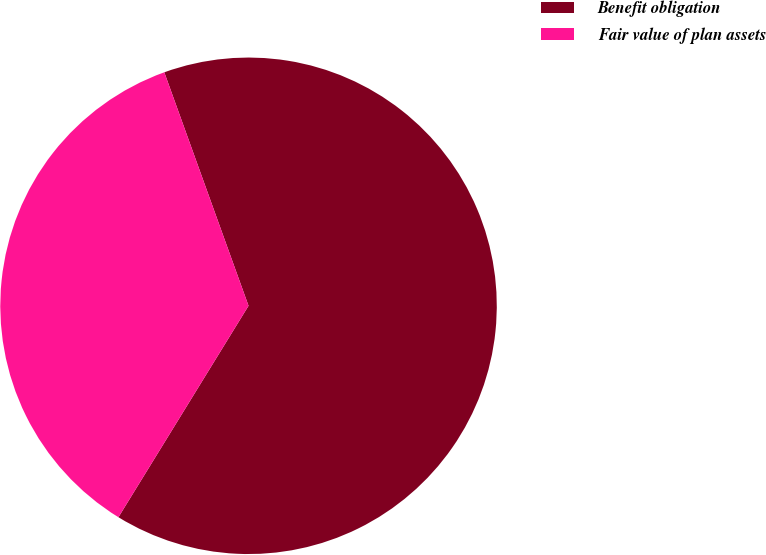Convert chart. <chart><loc_0><loc_0><loc_500><loc_500><pie_chart><fcel>Benefit obligation<fcel>Fair value of plan assets<nl><fcel>64.29%<fcel>35.71%<nl></chart> 